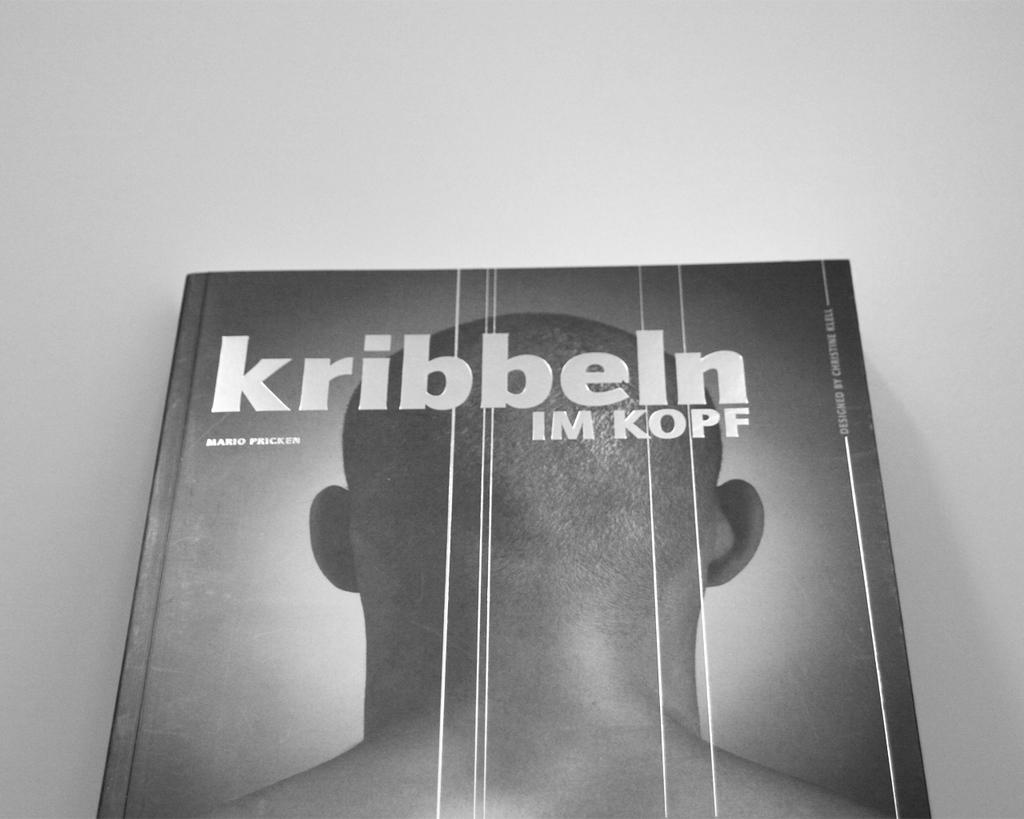<image>
Relay a brief, clear account of the picture shown. A book name Kribbeln Im Kopf written by Mario Pricker sits face up. 